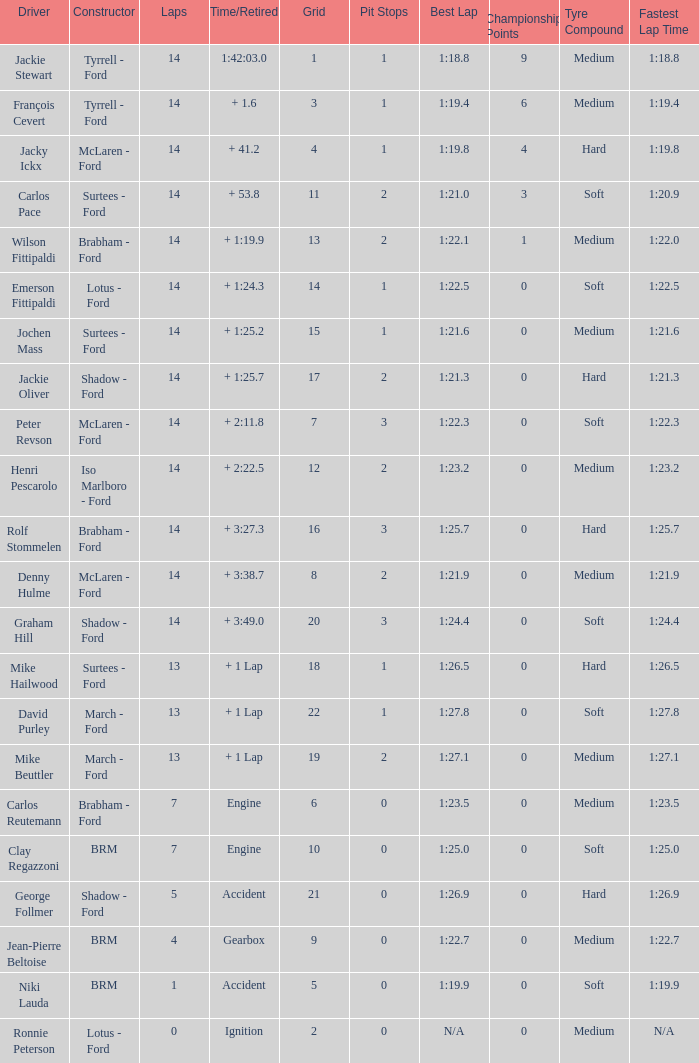What is the low lap total for henri pescarolo with a grad larger than 6? 14.0. 